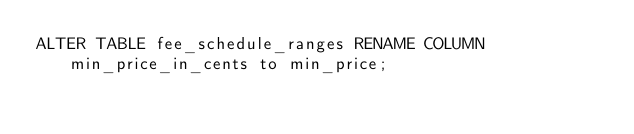<code> <loc_0><loc_0><loc_500><loc_500><_SQL_>ALTER TABLE fee_schedule_ranges RENAME COLUMN min_price_in_cents to min_price;
</code> 